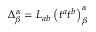<formula> <loc_0><loc_0><loc_500><loc_500>\Delta _ { \beta } ^ { \alpha } = L _ { a b } \left ( t ^ { a } t ^ { b } \right ) _ { \beta } ^ { \alpha }</formula> 